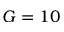Convert formula to latex. <formula><loc_0><loc_0><loc_500><loc_500>G = 1 0</formula> 